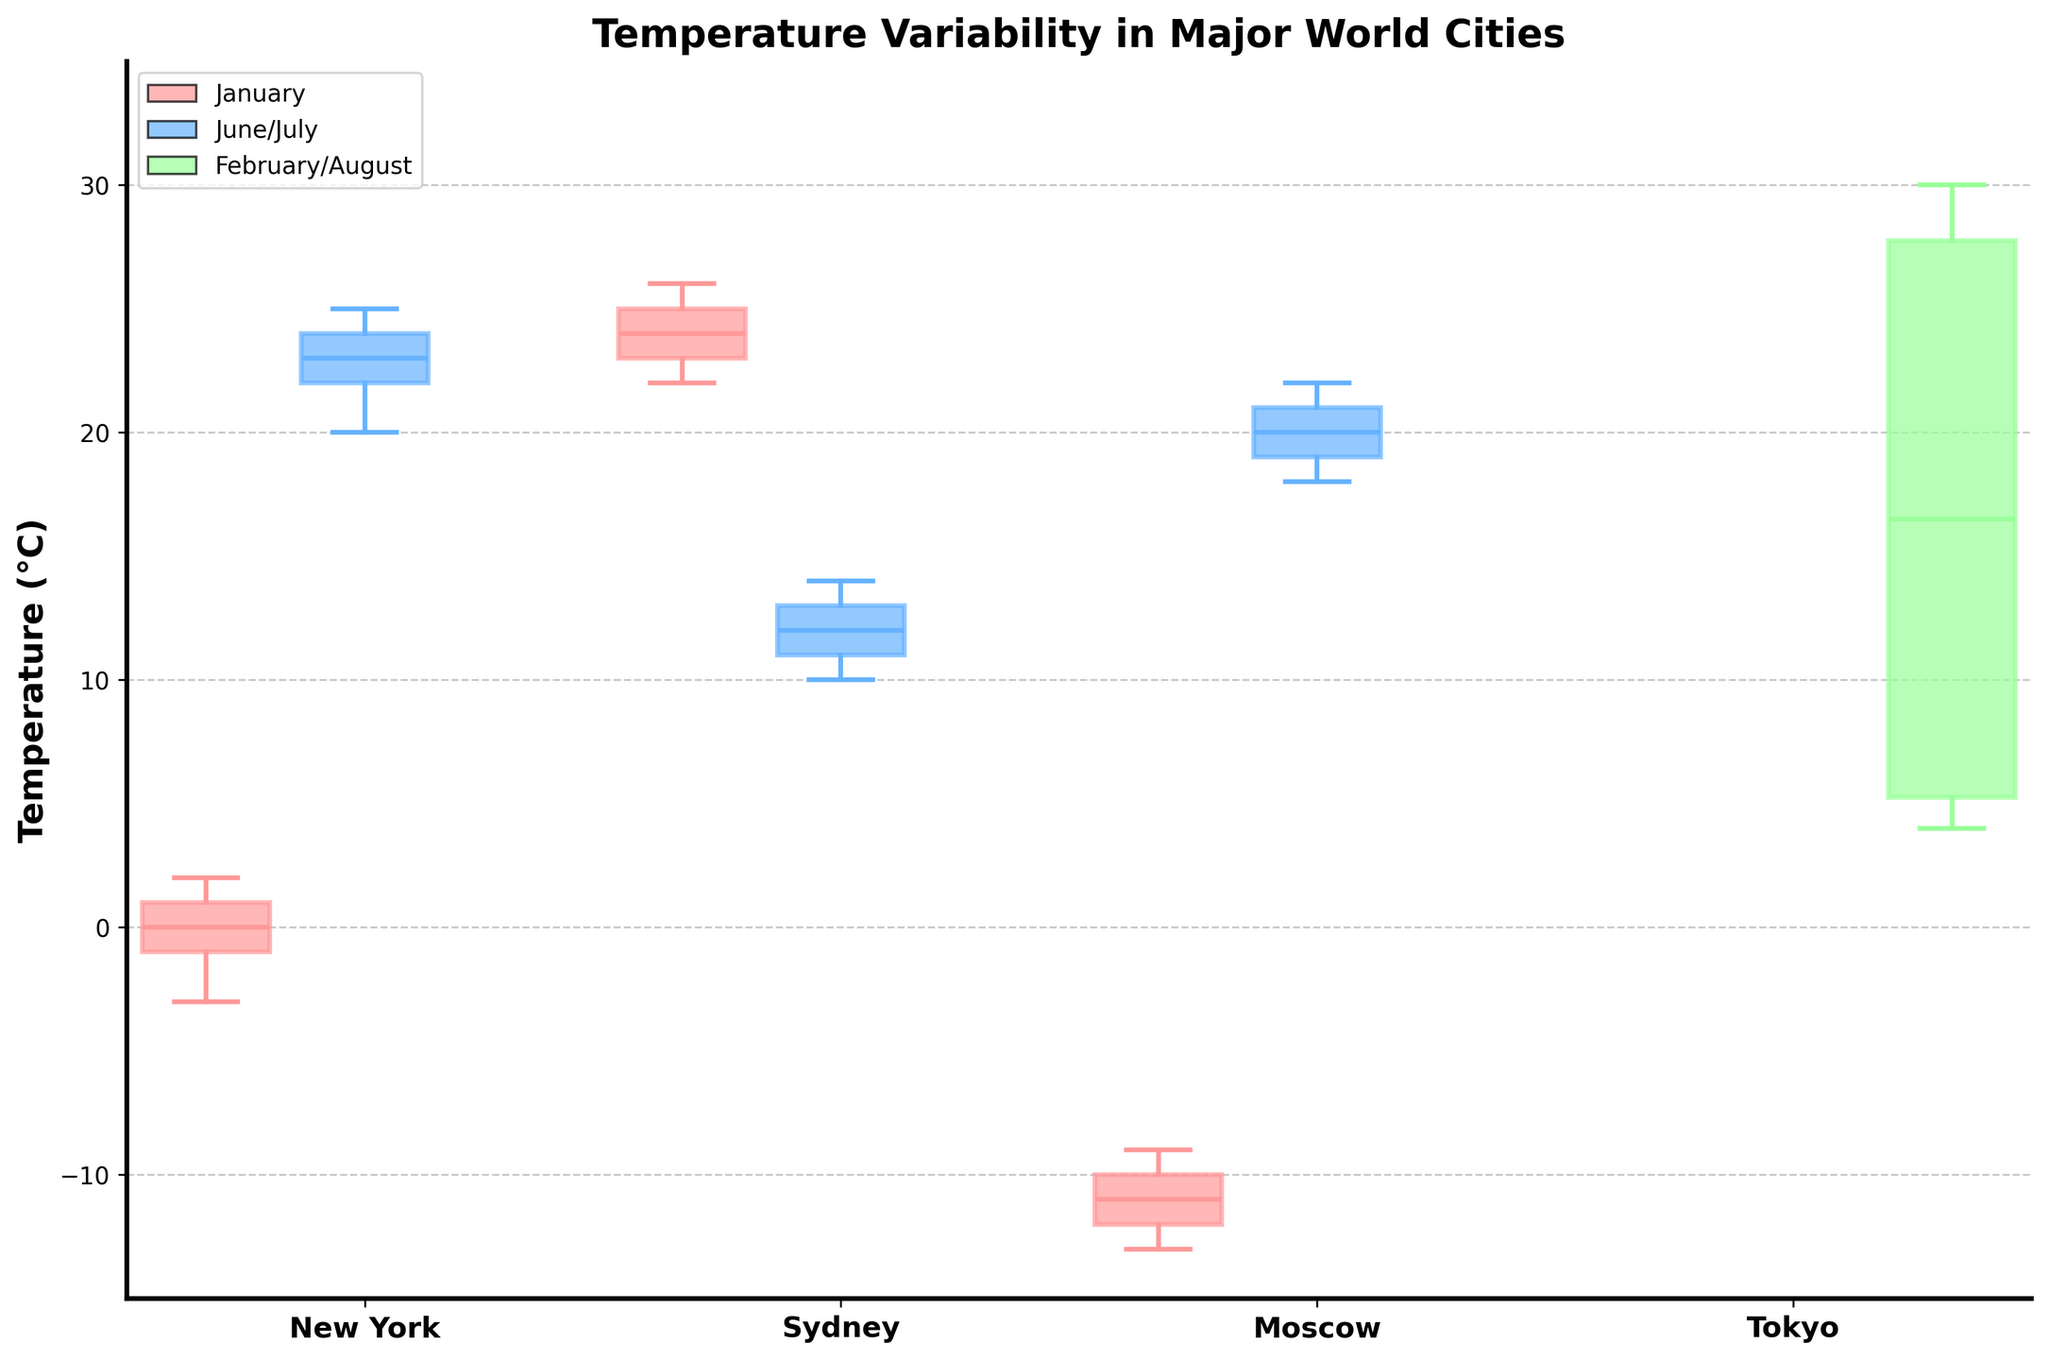What is the title of the figure? The title is usually written at the top of the figure in large, bold font. In this case, the title of the figure is "Temperature Variability in Major World Cities".
Answer: Temperature Variability in Major World Cities How many cities are represented in the figure? To count the number of cities, look at the x-axis labels. There are four city names: "New York", "Sydney", "Moscow", and "Tokyo".
Answer: 4 Which city has the highest median temperature in February/August? Look at the boxes on the plot for February/August and find the one with the highest line in the middle (median). Tokyo has the highest median around 28°C in August.
Answer: Tokyo Which month shows the lowest temperature variability for Moscow? Look at the length of the boxes (interquartile range) for Moscow. In January, the box is smaller compared to July, indicating lower variability.
Answer: January Compare the temperature ranges for New York in January and June. Which month has a greater range of temperatures? To find the range, compare the whiskers (minimum and maximum) of the boxes for New York in January and June. The range in January is from -3 to 2 (5 degrees), while in June it is from 20 to 25 (5 degrees). Both months have the same range.
Answer: Both months have the same range Which city has the highest interquartile range (IQR) in June/July? The IQR is measured by the height of the box. For June/July, compare the heights of the boxes for each city. Moscow has the largest IQR.
Answer: Moscow What is the median temperature for New York in June? Locate the median line inside the box for New York in June. The median temperature is at 23°C.
Answer: 23°C Is there any month where any of the cities have an outlier? Outliers are represented by dots outside the whiskers. Checking all months and cities, no outliers are visible.
Answer: No Compare Sydney's median temperatures between January and July. What is the difference? Find the median lines in the boxes for Sydney in January and July. The median in January is around 24.5°C and in July is around 12.5°C. The difference is 12°C.
Answer: 12°C Which city has the smallest interquartile range (IQR) in January? Compare the heights of the January boxes for all cities. New York has the smallest IQR.
Answer: New York 